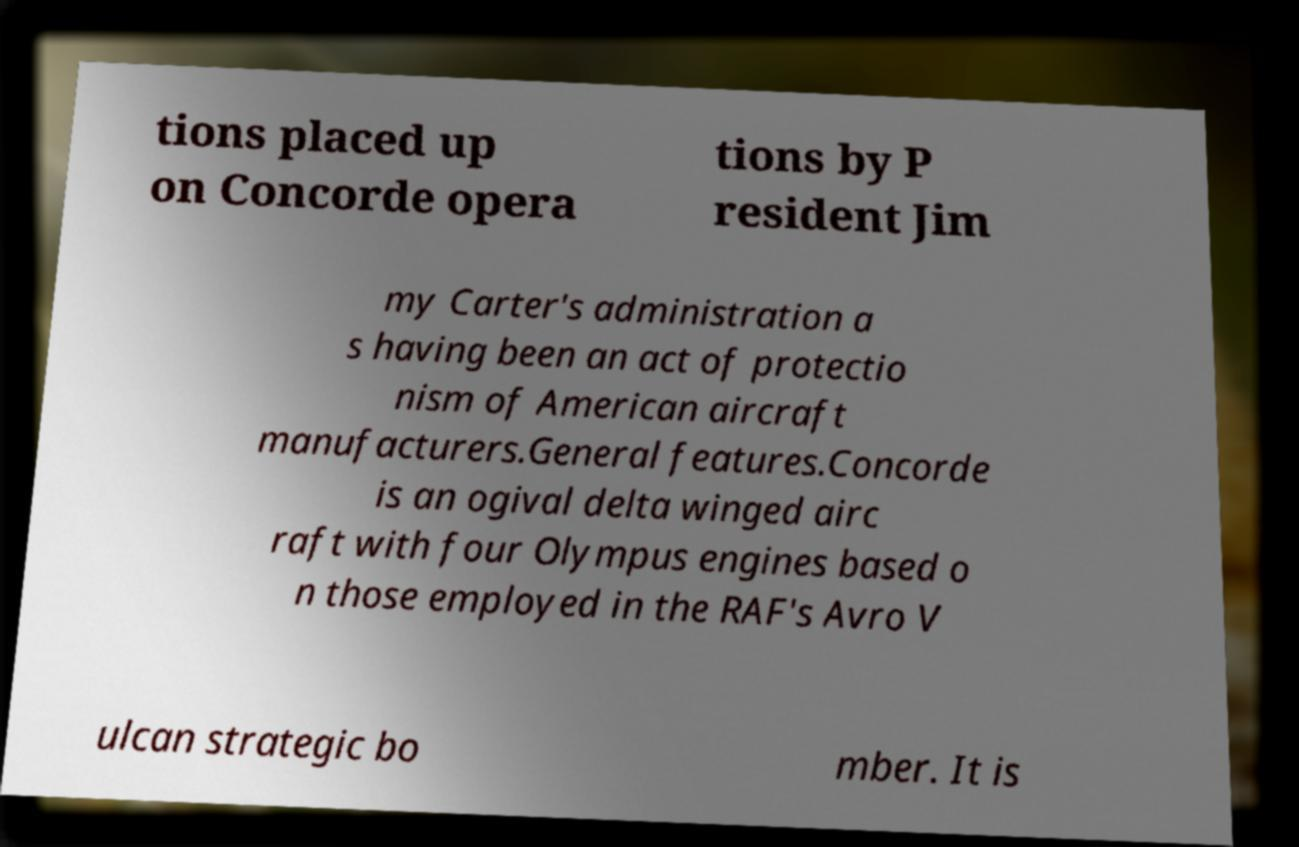I need the written content from this picture converted into text. Can you do that? tions placed up on Concorde opera tions by P resident Jim my Carter's administration a s having been an act of protectio nism of American aircraft manufacturers.General features.Concorde is an ogival delta winged airc raft with four Olympus engines based o n those employed in the RAF's Avro V ulcan strategic bo mber. It is 